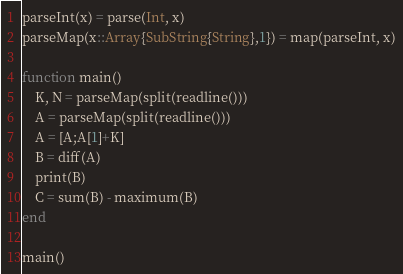<code> <loc_0><loc_0><loc_500><loc_500><_Julia_>parseInt(x) = parse(Int, x)
parseMap(x::Array{SubString{String},1}) = map(parseInt, x)

function main()
    K, N = parseMap(split(readline()))
    A = parseMap(split(readline()))
    A = [A;A[1]+K]
    B = diff(A)
    print(B)
    C = sum(B) - maximum(B)
end

main()</code> 